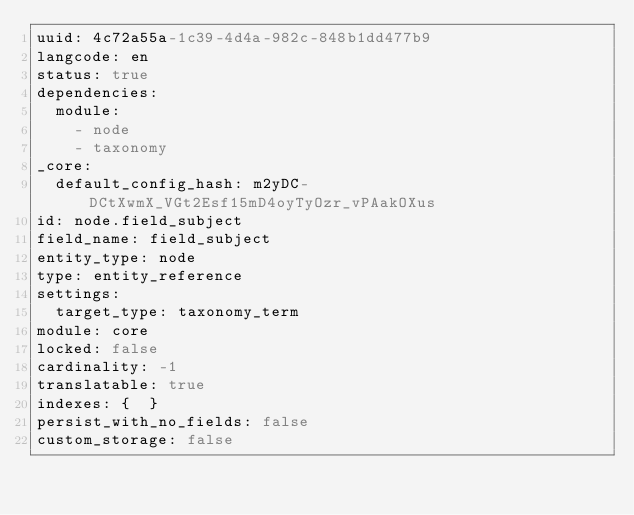<code> <loc_0><loc_0><loc_500><loc_500><_YAML_>uuid: 4c72a55a-1c39-4d4a-982c-848b1dd477b9
langcode: en
status: true
dependencies:
  module:
    - node
    - taxonomy
_core:
  default_config_hash: m2yDC-DCtXwmX_VGt2Esf15mD4oyTyOzr_vPAakOXus
id: node.field_subject
field_name: field_subject
entity_type: node
type: entity_reference
settings:
  target_type: taxonomy_term
module: core
locked: false
cardinality: -1
translatable: true
indexes: {  }
persist_with_no_fields: false
custom_storage: false
</code> 